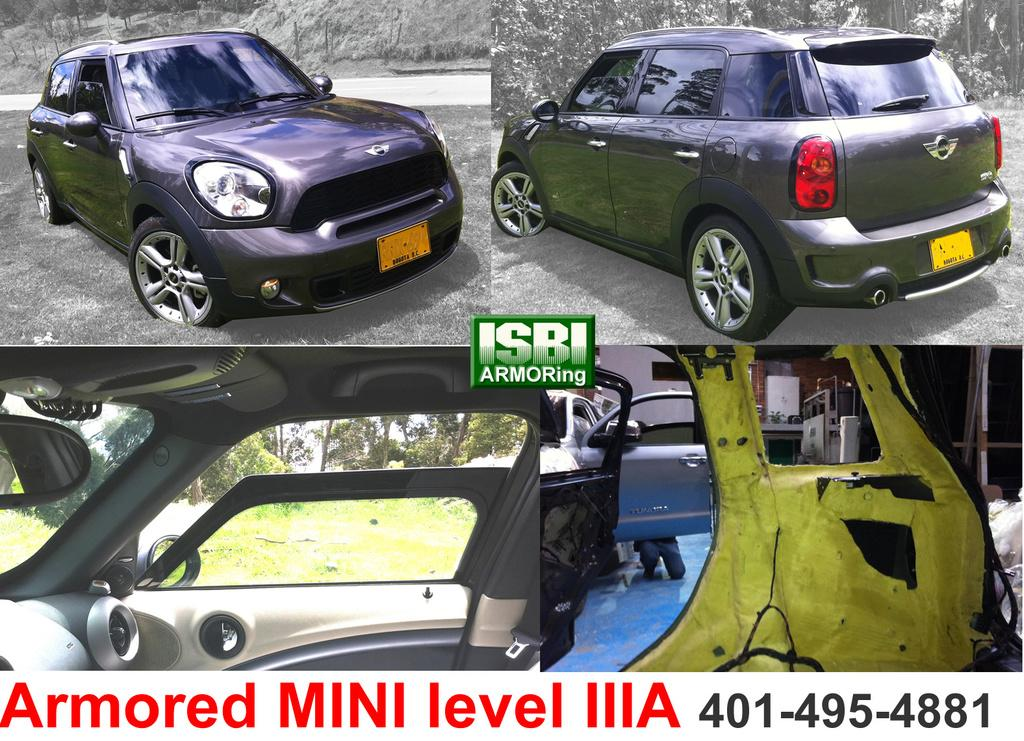What type of artwork is the image? The image is a collage. What types of vehicles can be seen in the collage? There are vehicles in the image. What other natural elements are present in the collage? There are trees in the image. Can you describe the background of the collage? The sky is visible in the background of the image. Are there any other objects or elements in the collage? Yes, there are other objects in the image. What is the outcome of the argument between the bucket and the basketball in the image? There is no argument between a bucket and a basketball in the image, as neither of these objects is present. 